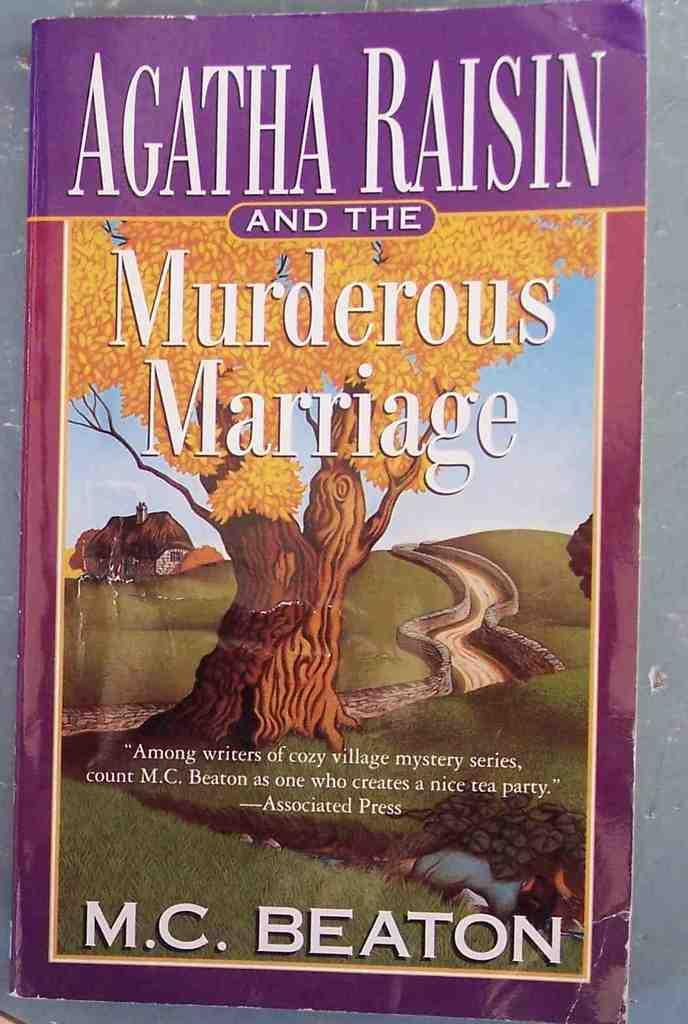Provide a one-sentence caption for the provided image. The cover of a fictional book about marriage. 